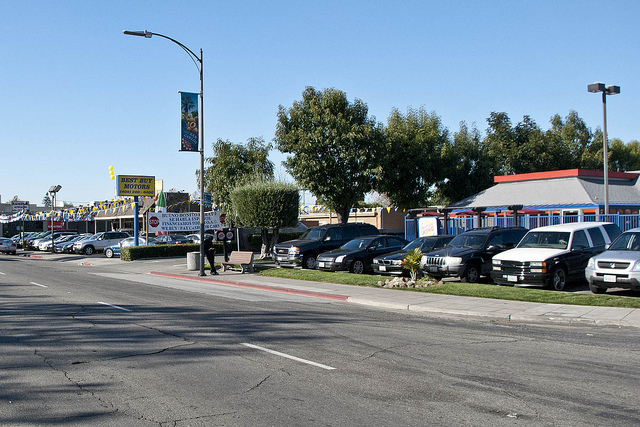<image>How is traffic? It's ambiguous how the traffic is. Some say it's good, light or even non-existent, while others have mentioned it's slow. What is the name of the oil change business advertised in the photo? I am not sure about the name of the oil change business advertised in the photo. It could be 'best buy motors' or 'jiffy lube'. What is the name of the oil change business advertised in the photo? The name of the oil change business advertised in the photo is Best Buy Motors. How is traffic? I don't know how the traffic is. It can be good, light, no traffic, empty, slow or clear. 